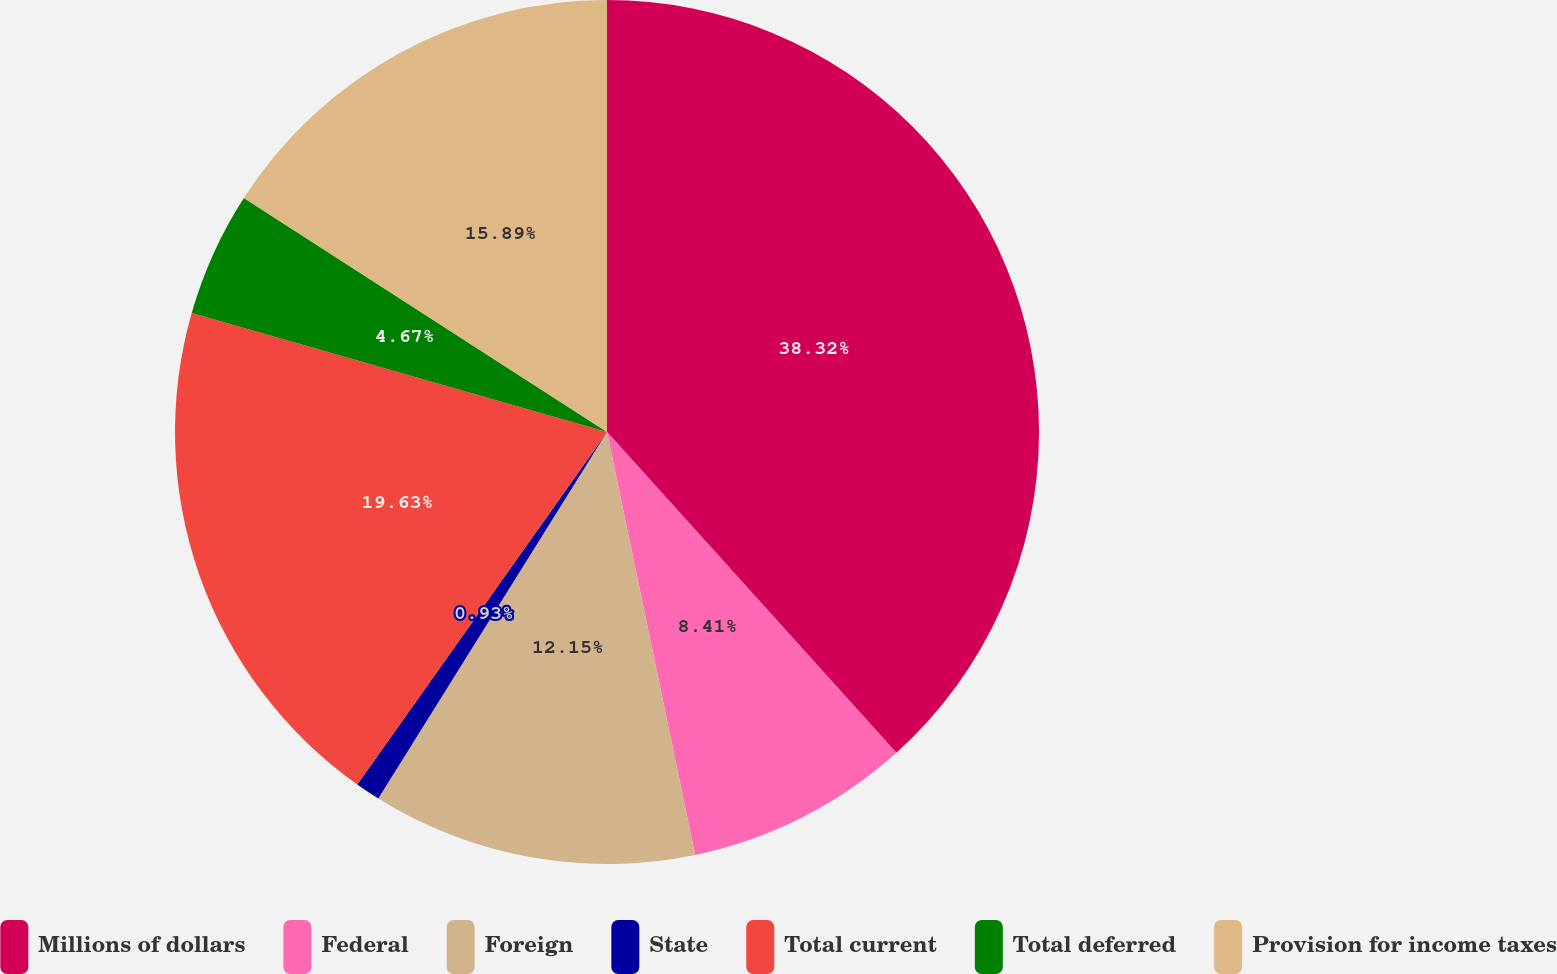Convert chart. <chart><loc_0><loc_0><loc_500><loc_500><pie_chart><fcel>Millions of dollars<fcel>Federal<fcel>Foreign<fcel>State<fcel>Total current<fcel>Total deferred<fcel>Provision for income taxes<nl><fcel>38.32%<fcel>8.41%<fcel>12.15%<fcel>0.93%<fcel>19.63%<fcel>4.67%<fcel>15.89%<nl></chart> 